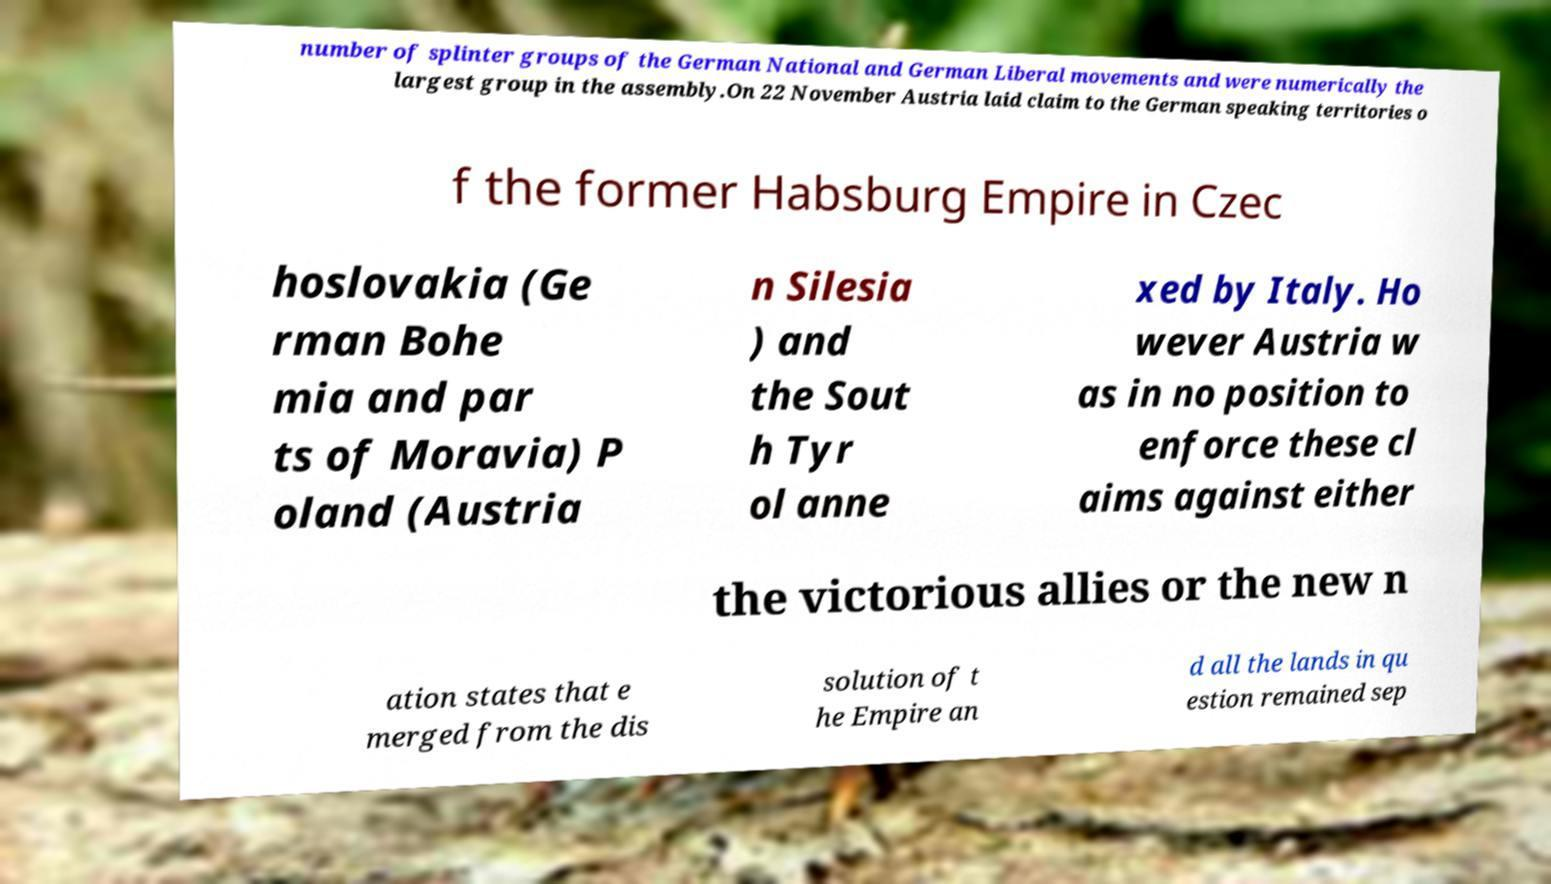Could you assist in decoding the text presented in this image and type it out clearly? number of splinter groups of the German National and German Liberal movements and were numerically the largest group in the assembly.On 22 November Austria laid claim to the German speaking territories o f the former Habsburg Empire in Czec hoslovakia (Ge rman Bohe mia and par ts of Moravia) P oland (Austria n Silesia ) and the Sout h Tyr ol anne xed by Italy. Ho wever Austria w as in no position to enforce these cl aims against either the victorious allies or the new n ation states that e merged from the dis solution of t he Empire an d all the lands in qu estion remained sep 